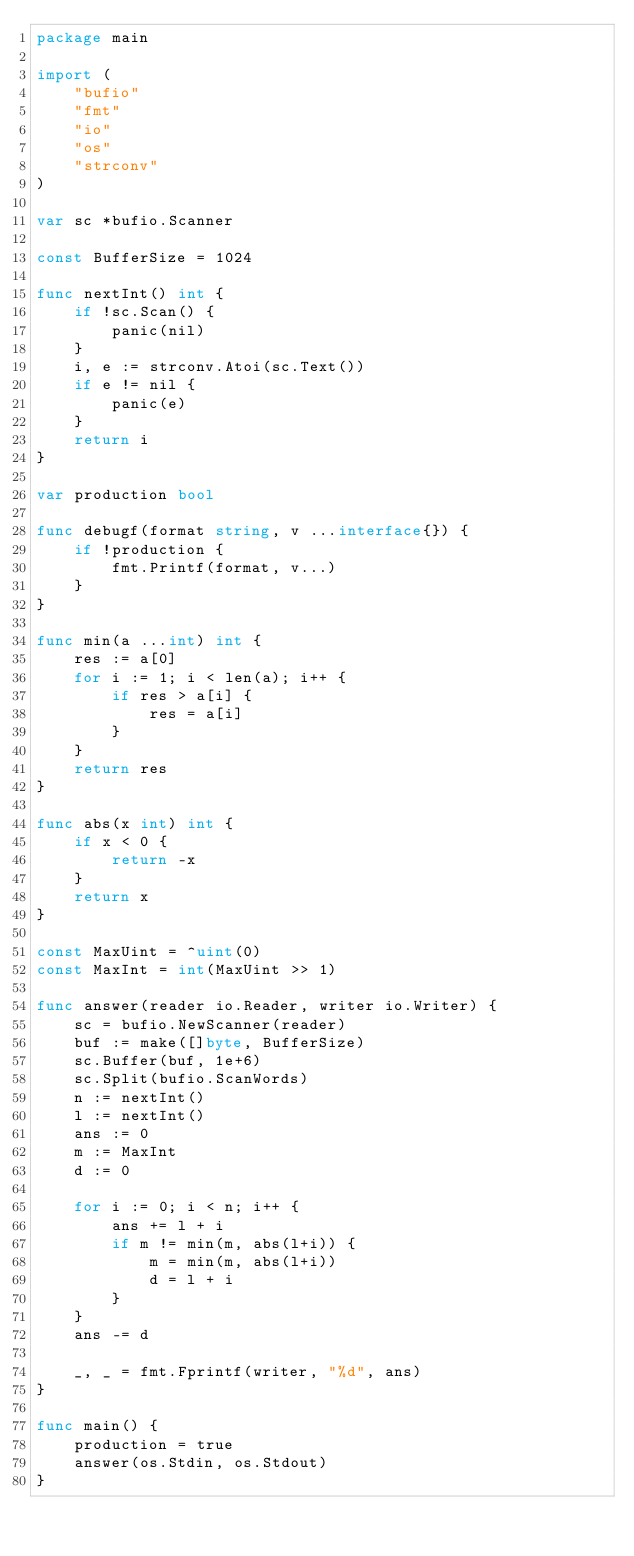Convert code to text. <code><loc_0><loc_0><loc_500><loc_500><_Go_>package main

import (
	"bufio"
	"fmt"
	"io"
	"os"
	"strconv"
)

var sc *bufio.Scanner

const BufferSize = 1024

func nextInt() int {
	if !sc.Scan() {
		panic(nil)
	}
	i, e := strconv.Atoi(sc.Text())
	if e != nil {
		panic(e)
	}
	return i
}

var production bool

func debugf(format string, v ...interface{}) {
	if !production {
		fmt.Printf(format, v...)
	}
}

func min(a ...int) int {
	res := a[0]
	for i := 1; i < len(a); i++ {
		if res > a[i] {
			res = a[i]
		}
	}
	return res
}

func abs(x int) int {
	if x < 0 {
		return -x
	}
	return x
}

const MaxUint = ^uint(0)
const MaxInt = int(MaxUint >> 1)

func answer(reader io.Reader, writer io.Writer) {
	sc = bufio.NewScanner(reader)
	buf := make([]byte, BufferSize)
	sc.Buffer(buf, 1e+6)
	sc.Split(bufio.ScanWords)
	n := nextInt()
	l := nextInt()
	ans := 0
	m := MaxInt
	d := 0

	for i := 0; i < n; i++ {
		ans += l + i
		if m != min(m, abs(l+i)) {
			m = min(m, abs(l+i))
			d = l + i
		}
	}
	ans -= d

	_, _ = fmt.Fprintf(writer, "%d", ans)
}

func main() {
	production = true
	answer(os.Stdin, os.Stdout)
}
</code> 